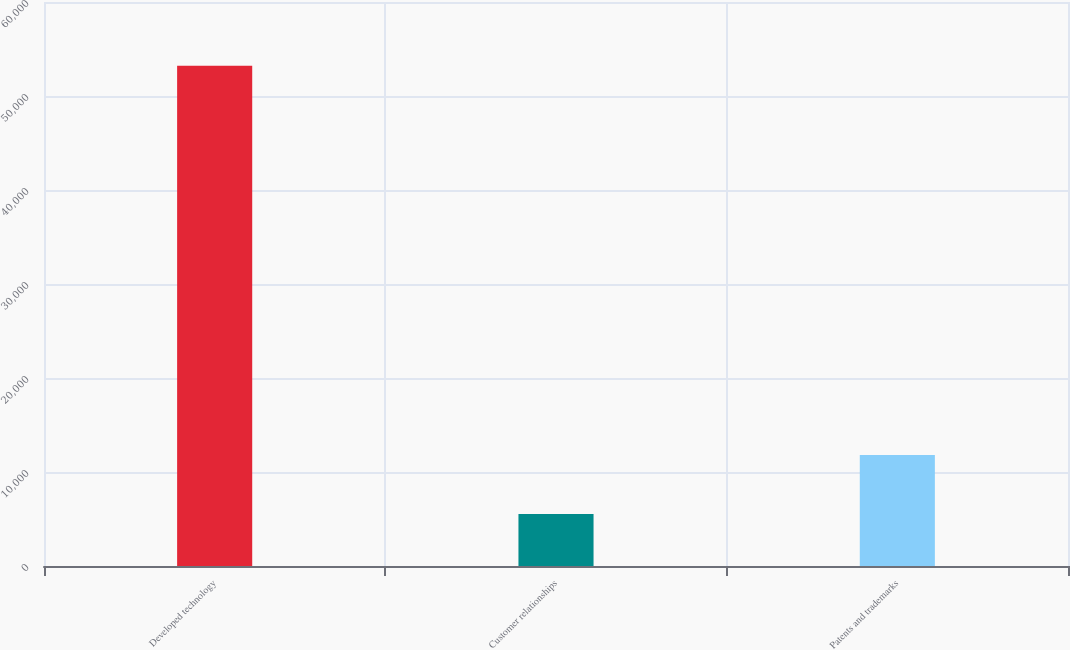<chart> <loc_0><loc_0><loc_500><loc_500><bar_chart><fcel>Developed technology<fcel>Customer relationships<fcel>Patents and trademarks<nl><fcel>53213<fcel>5533<fcel>11800<nl></chart> 